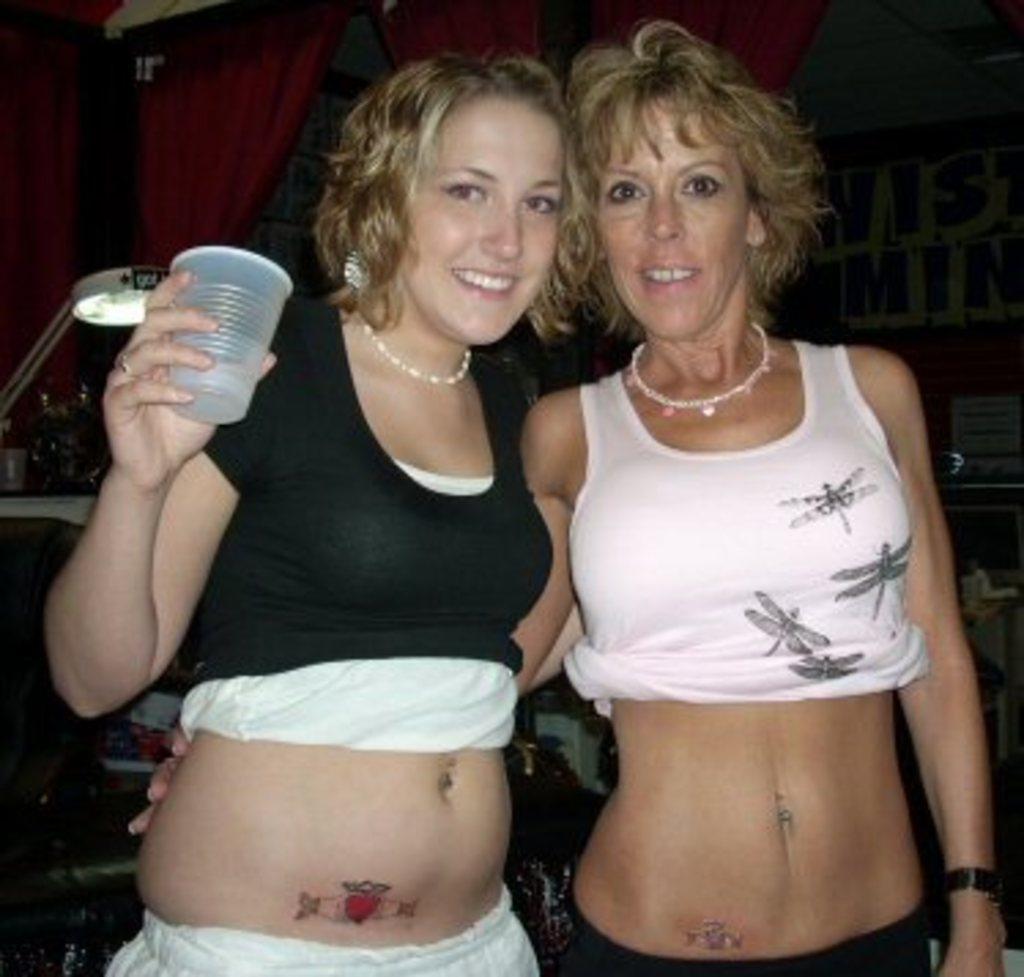Could you give a brief overview of what you see in this image? In this picture I can see two women standing with a smile. I can see the curtains. I can see light on the left side. I can see a woman on the left holding a glass. 